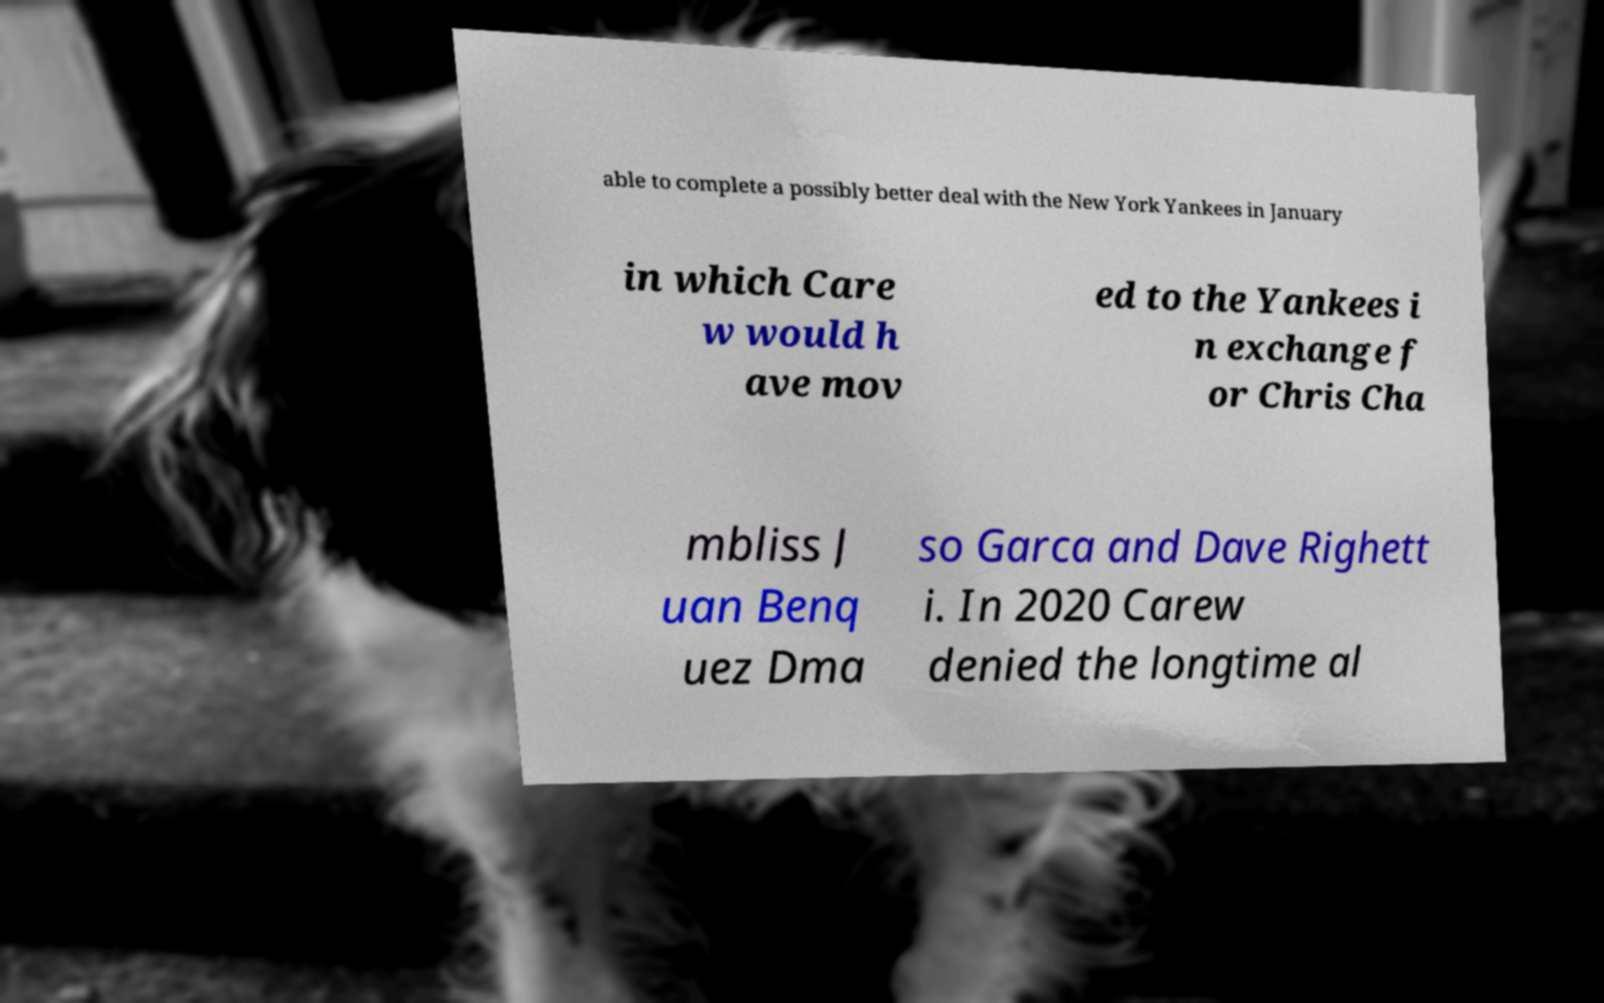Can you accurately transcribe the text from the provided image for me? able to complete a possibly better deal with the New York Yankees in January in which Care w would h ave mov ed to the Yankees i n exchange f or Chris Cha mbliss J uan Benq uez Dma so Garca and Dave Righett i. In 2020 Carew denied the longtime al 